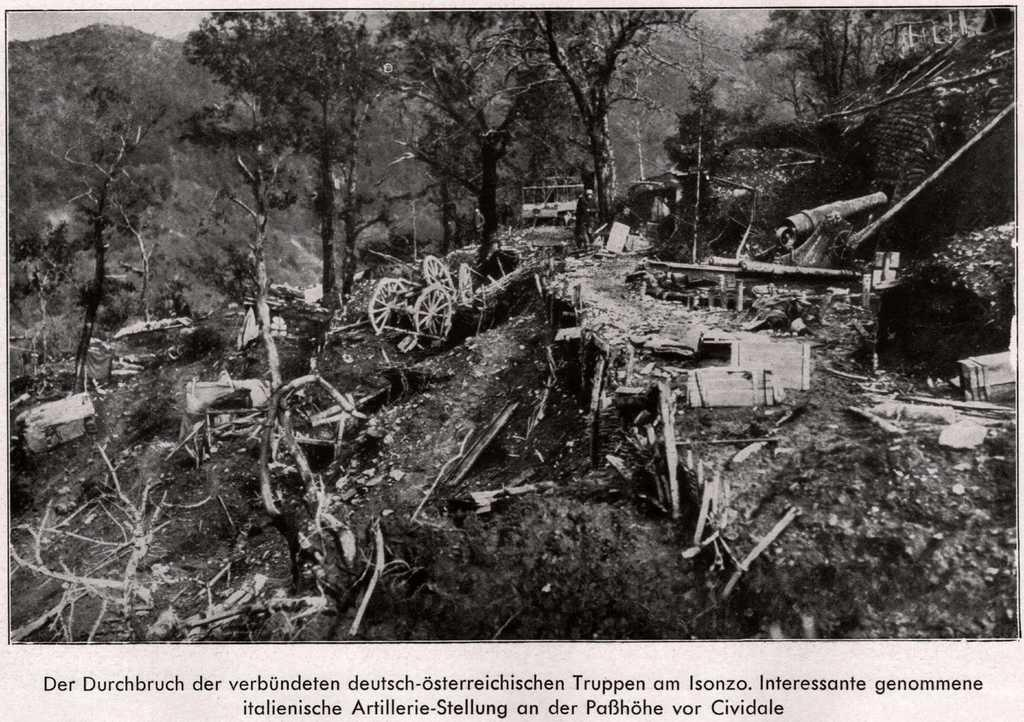What is the color scheme of the image? The image is black and white. What type of objects can be seen in the image? There are wooden objects in the image. What kind of vehicle is present in the image? There is a vehicle in the image. What natural elements are visible in the image? There are trees and the sky visible in the image. Where is the rake being used in the image? There is no rake present in the image. What type of boot is visible on the vehicle in the image? There is no boot visible on the vehicle in the image. 